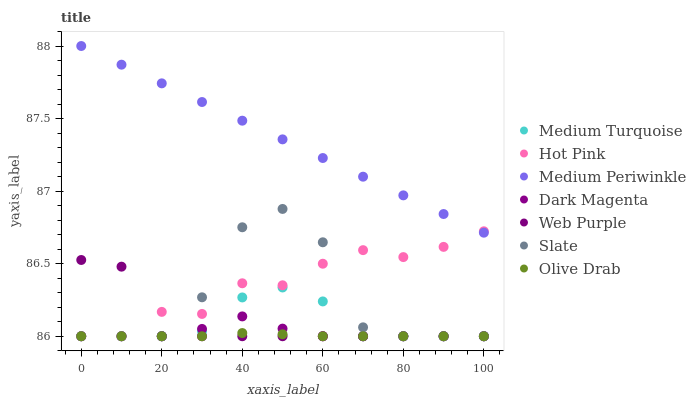Does Olive Drab have the minimum area under the curve?
Answer yes or no. Yes. Does Medium Periwinkle have the maximum area under the curve?
Answer yes or no. Yes. Does Slate have the minimum area under the curve?
Answer yes or no. No. Does Slate have the maximum area under the curve?
Answer yes or no. No. Is Medium Periwinkle the smoothest?
Answer yes or no. Yes. Is Slate the roughest?
Answer yes or no. Yes. Is Hot Pink the smoothest?
Answer yes or no. No. Is Hot Pink the roughest?
Answer yes or no. No. Does Dark Magenta have the lowest value?
Answer yes or no. Yes. Does Medium Periwinkle have the lowest value?
Answer yes or no. No. Does Medium Periwinkle have the highest value?
Answer yes or no. Yes. Does Slate have the highest value?
Answer yes or no. No. Is Web Purple less than Medium Periwinkle?
Answer yes or no. Yes. Is Medium Periwinkle greater than Web Purple?
Answer yes or no. Yes. Does Hot Pink intersect Olive Drab?
Answer yes or no. Yes. Is Hot Pink less than Olive Drab?
Answer yes or no. No. Is Hot Pink greater than Olive Drab?
Answer yes or no. No. Does Web Purple intersect Medium Periwinkle?
Answer yes or no. No. 